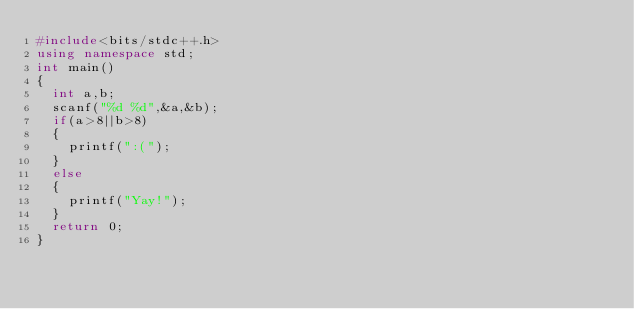Convert code to text. <code><loc_0><loc_0><loc_500><loc_500><_C++_>#include<bits/stdc++.h>
using namespace std;
int main()
{
	int a,b;
	scanf("%d %d",&a,&b);
	if(a>8||b>8)
	{
		printf(":("); 
	}
	else
	{
		printf("Yay!");
	}
	return 0;
}</code> 